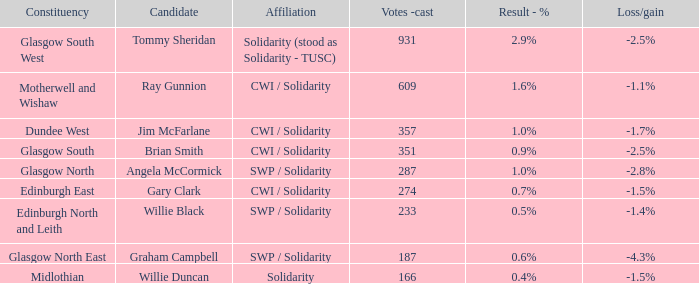Who was the contender when the result - % was Tommy Sheridan. Could you parse the entire table? {'header': ['Constituency', 'Candidate', 'Affiliation', 'Votes -cast', 'Result - %', 'Loss/gain'], 'rows': [['Glasgow South West', 'Tommy Sheridan', 'Solidarity (stood as Solidarity - TUSC)', '931', '2.9%', '-2.5%'], ['Motherwell and Wishaw', 'Ray Gunnion', 'CWI / Solidarity', '609', '1.6%', '-1.1%'], ['Dundee West', 'Jim McFarlane', 'CWI / Solidarity', '357', '1.0%', '-1.7%'], ['Glasgow South', 'Brian Smith', 'CWI / Solidarity', '351', '0.9%', '-2.5%'], ['Glasgow North', 'Angela McCormick', 'SWP / Solidarity', '287', '1.0%', '-2.8%'], ['Edinburgh East', 'Gary Clark', 'CWI / Solidarity', '274', '0.7%', '-1.5%'], ['Edinburgh North and Leith', 'Willie Black', 'SWP / Solidarity', '233', '0.5%', '-1.4%'], ['Glasgow North East', 'Graham Campbell', 'SWP / Solidarity', '187', '0.6%', '-4.3%'], ['Midlothian', 'Willie Duncan', 'Solidarity', '166', '0.4%', '-1.5%']]} 